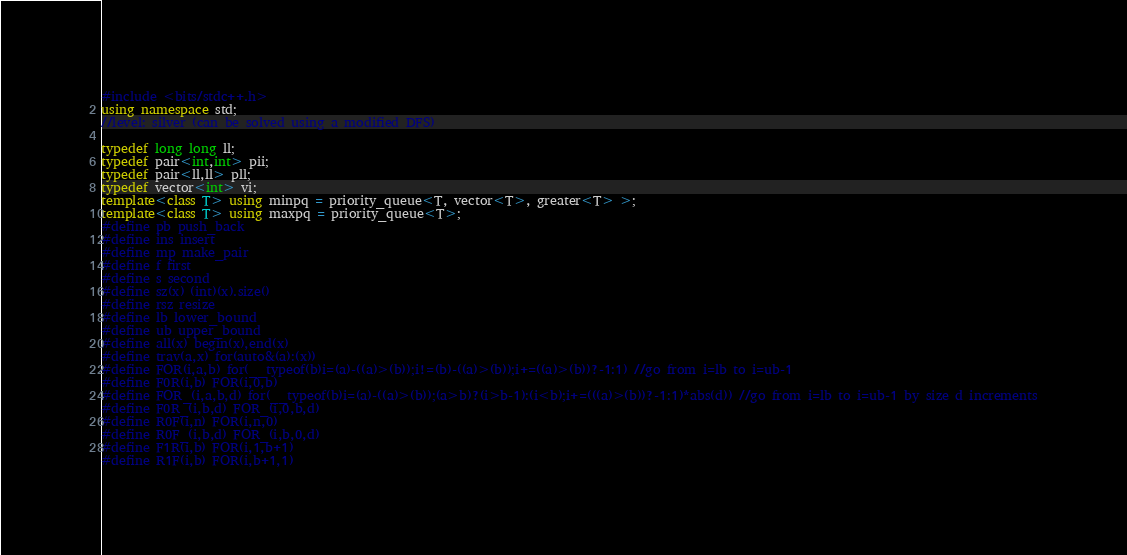Convert code to text. <code><loc_0><loc_0><loc_500><loc_500><_C++_>#include <bits/stdc++.h>
using namespace std;
//level: silver (can be solved using a modified DFS)

typedef long long ll;
typedef pair<int,int> pii;
typedef pair<ll,ll> pll;
typedef vector<int> vi;
template<class T> using minpq = priority_queue<T, vector<T>, greater<T> >;
template<class T> using maxpq = priority_queue<T>;
#define pb push_back
#define ins insert
#define mp make_pair
#define f first
#define s second
#define sz(x) (int)(x).size()
#define rsz resize
#define lb lower_bound
#define ub upper_bound
#define all(x) begin(x),end(x)
#define trav(a,x) for(auto&(a):(x))
#define FOR(i,a,b) for(__typeof(b)i=(a)-((a)>(b));i!=(b)-((a)>(b));i+=((a)>(b))?-1:1) //go from i=lb to i=ub-1
#define F0R(i,b) FOR(i,0,b)
#define FOR_(i,a,b,d) for(__typeof(b)i=(a)-((a)>(b));(a>b)?(i>b-1):(i<b);i+=(((a)>(b))?-1:1)*abs(d)) //go from i=lb to i=ub-1 by size d increments
#define F0R_(i,b,d) FOR_(i,0,b,d)
#define R0F(i,n) FOR(i,n,0)
#define R0F_(i,b,d) FOR_(i,b,0,d)
#define F1R(i,b) FOR(i,1,b+1)
#define R1F(i,b) FOR(i,b+1,1)</code> 